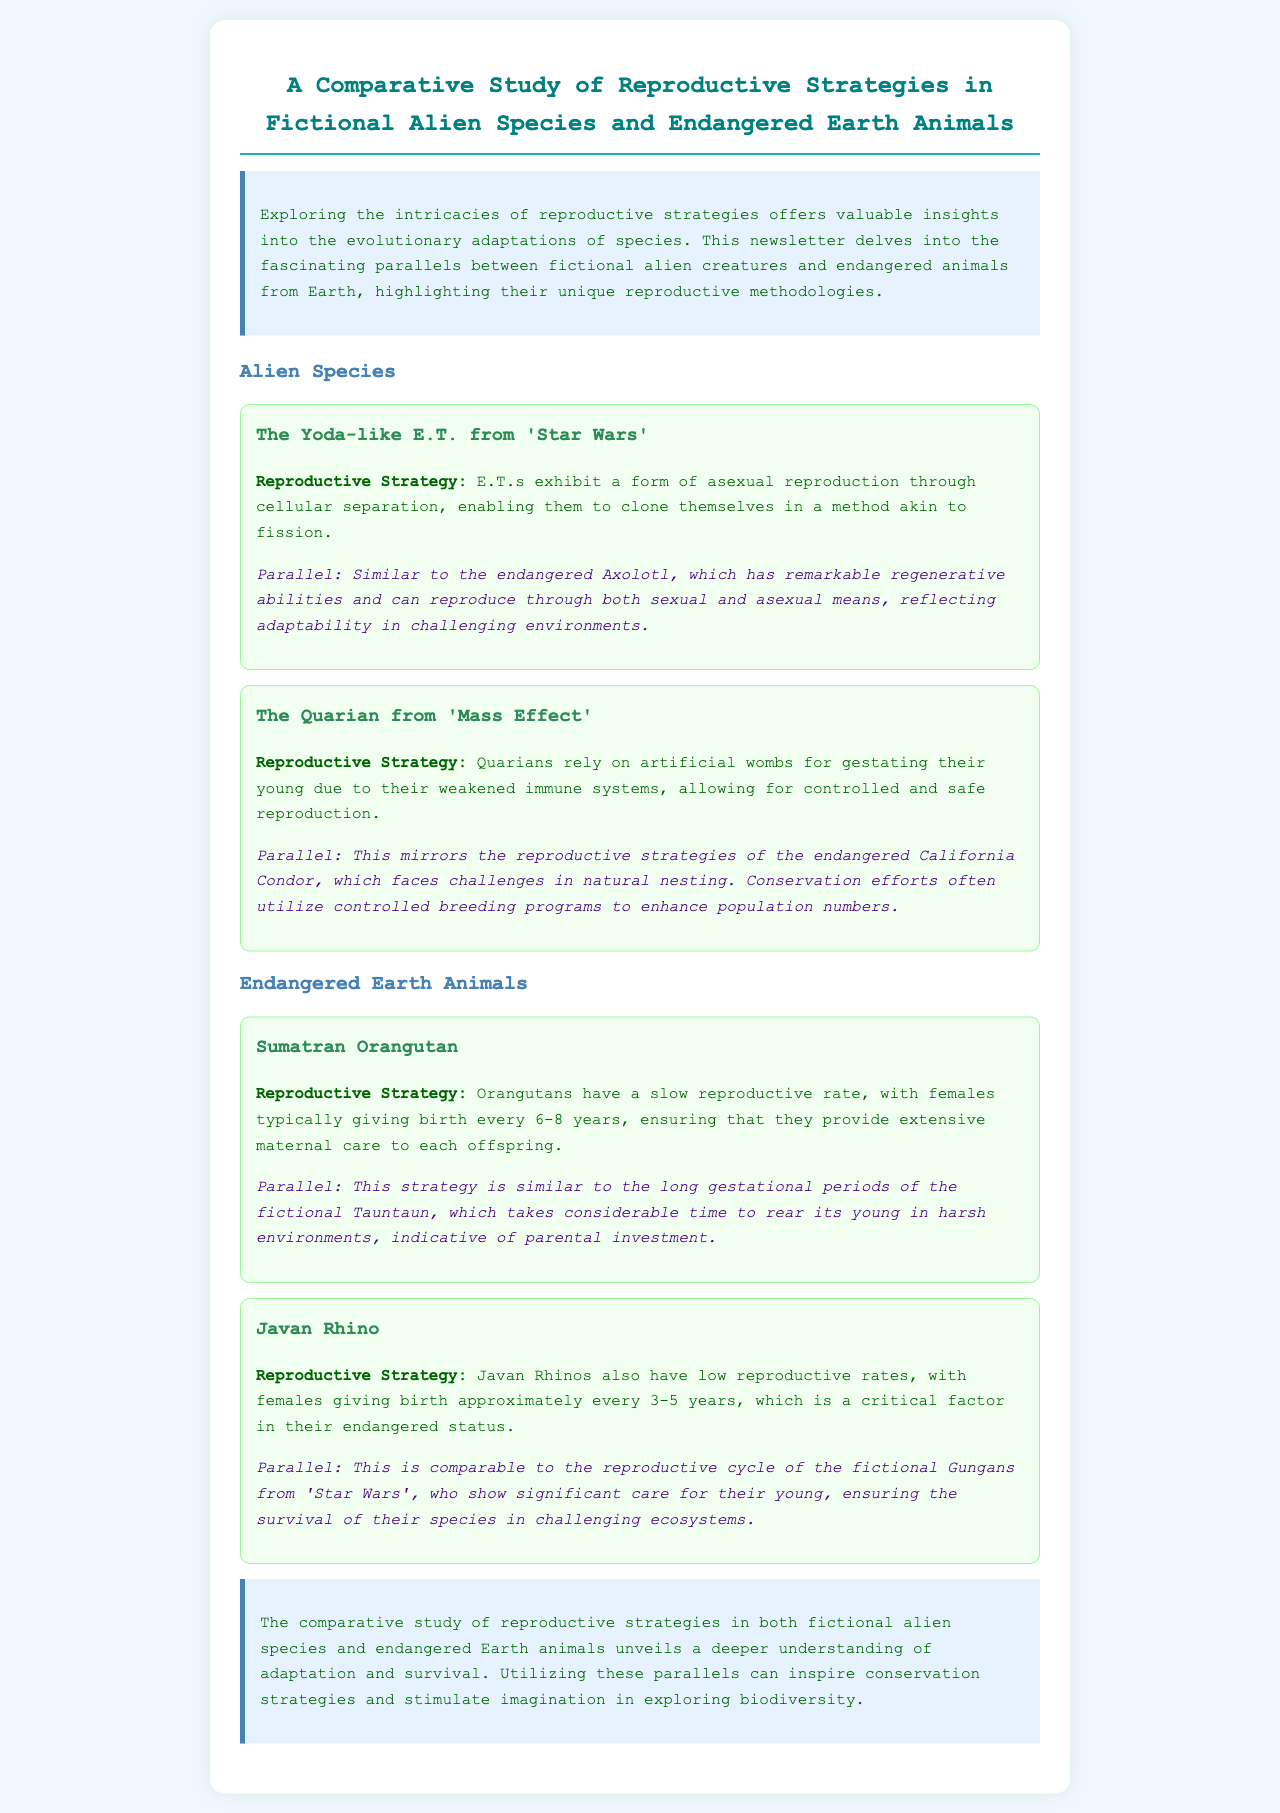What is the title of the newsletter? The title of the newsletter is provided at the beginning of the document, stating the subject it covers regarding reproductive strategies.
Answer: A Comparative Study of Reproductive Strategies in Fictional Alien Species and Endangered Earth Animals What reproductive strategy do E.T.s from 'Star Wars' exhibit? E.T.s' reproductive strategy is detailed under the alien species section, indicating how they reproduce.
Answer: Asexual reproduction through cellular separation What endangered animal is compared to the E.T.s? The comparison with E.T.s is drawn with a specific endangered animal mentioned in the document.
Answer: Axolotl How often do Sumatran Orangutans typically give birth? This information is outlined in the reproductive strategy of the Sumatran Orangutan within the document.
Answer: Every 6-8 years What is the reproductive strategy of the Javan Rhino? The strategy is given as part of the section focusing on endangered Earth animals, describing their reproductive behavior.
Answer: Low reproductive rates with females giving birth every 3-5 years What parallels are drawn between the Quarians and California Condors? The document discusses a specific aspect of their reproduction strategies that are similar in terms of controlled environments.
Answer: Controlled breeding programs How does the document describe the investment in Sumatran Orangutan offspring? The document highlights the level of parental care given by Sumatran Orangutans, which is discussed in their reproductive strategy.
Answer: Extensive maternal care What is a common theme in the comparative study of reproductive strategies? A key theme is reflected in the findings discussed towards the end of the document regarding adaptation.
Answer: Adaptation and survival 